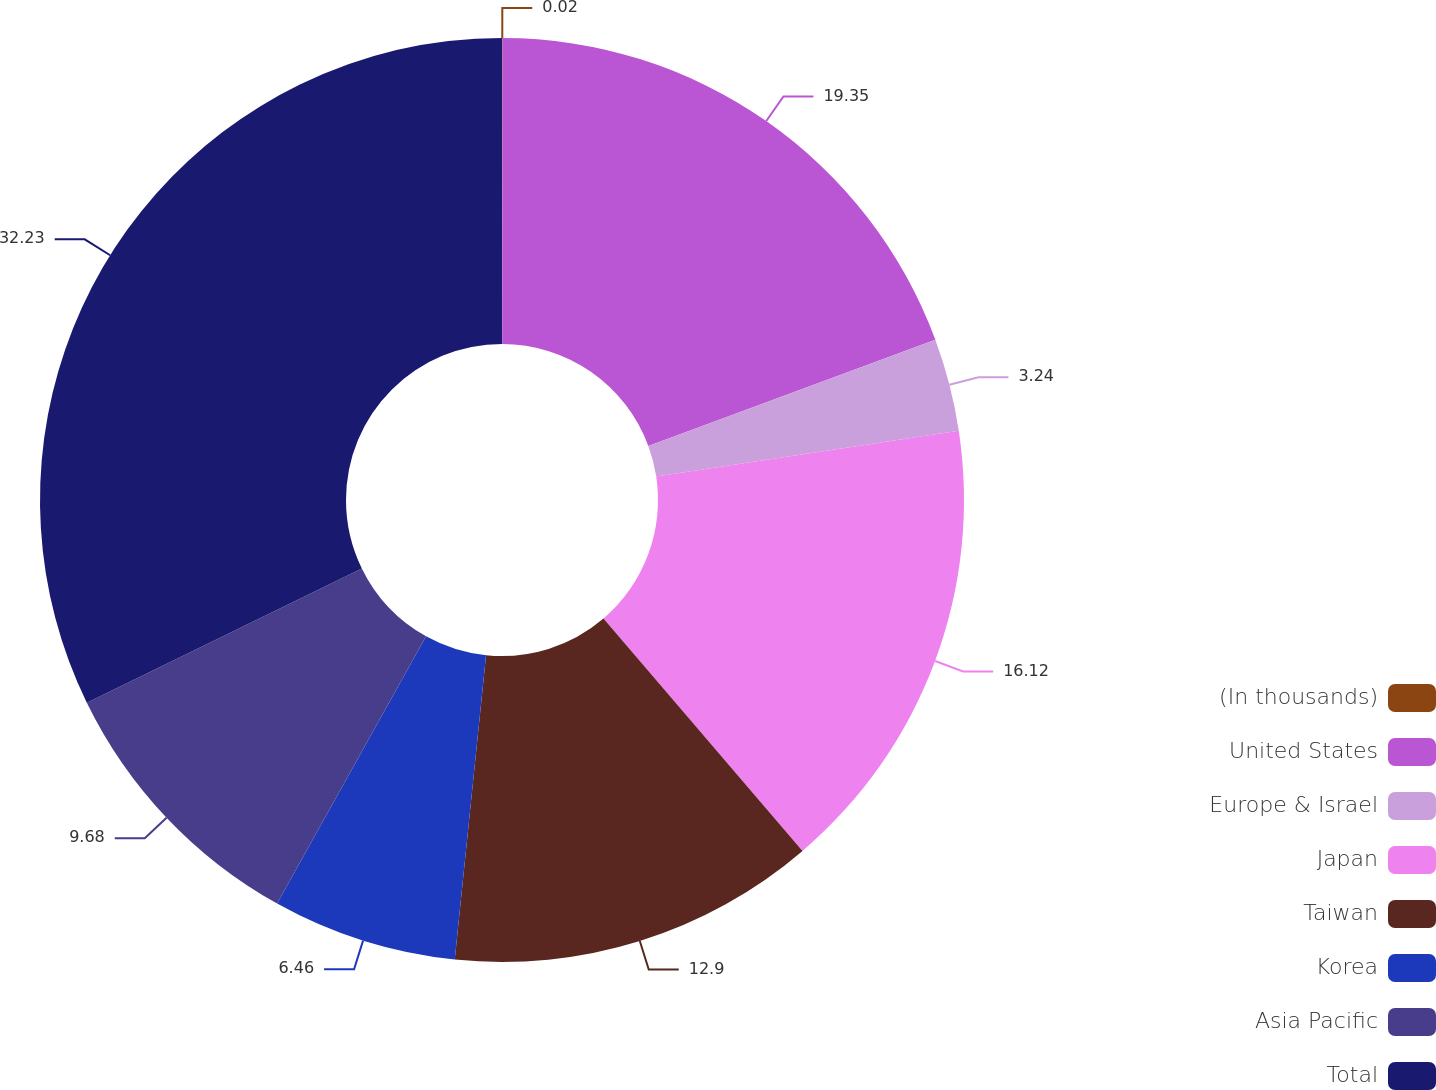Convert chart to OTSL. <chart><loc_0><loc_0><loc_500><loc_500><pie_chart><fcel>(In thousands)<fcel>United States<fcel>Europe & Israel<fcel>Japan<fcel>Taiwan<fcel>Korea<fcel>Asia Pacific<fcel>Total<nl><fcel>0.02%<fcel>19.34%<fcel>3.24%<fcel>16.12%<fcel>12.9%<fcel>6.46%<fcel>9.68%<fcel>32.22%<nl></chart> 